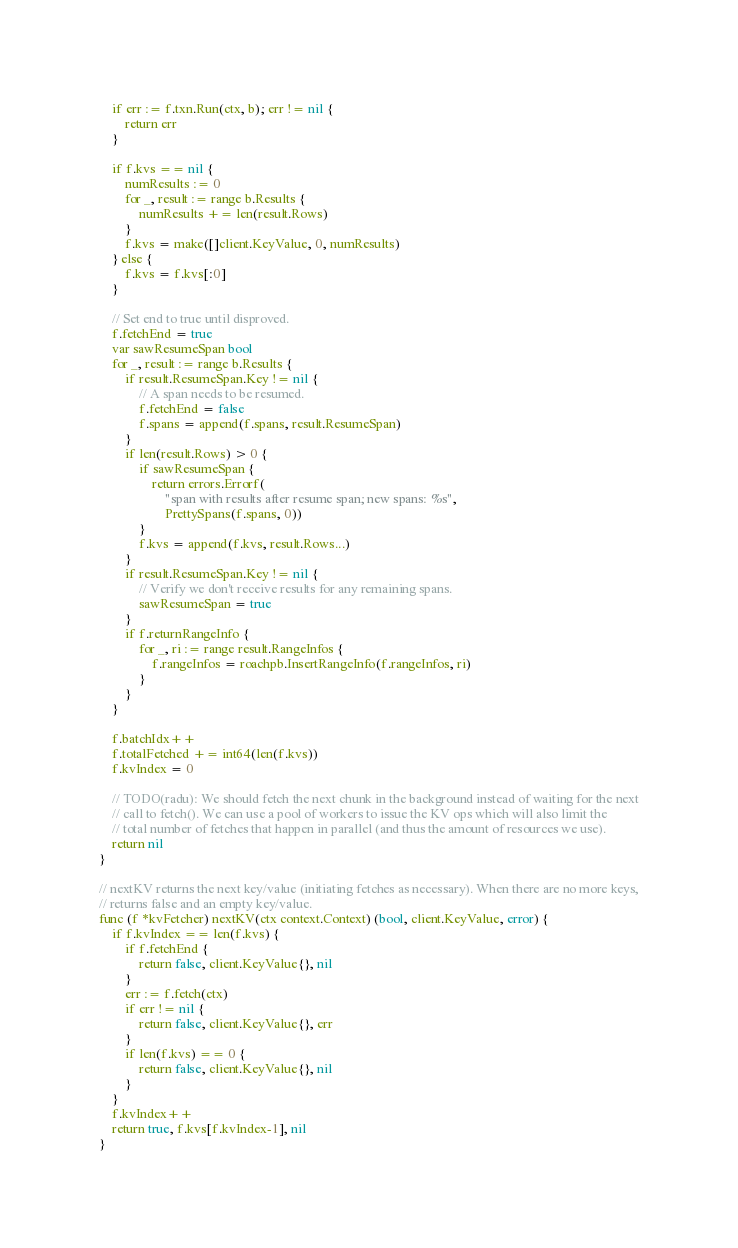<code> <loc_0><loc_0><loc_500><loc_500><_Go_>	if err := f.txn.Run(ctx, b); err != nil {
		return err
	}

	if f.kvs == nil {
		numResults := 0
		for _, result := range b.Results {
			numResults += len(result.Rows)
		}
		f.kvs = make([]client.KeyValue, 0, numResults)
	} else {
		f.kvs = f.kvs[:0]
	}

	// Set end to true until disproved.
	f.fetchEnd = true
	var sawResumeSpan bool
	for _, result := range b.Results {
		if result.ResumeSpan.Key != nil {
			// A span needs to be resumed.
			f.fetchEnd = false
			f.spans = append(f.spans, result.ResumeSpan)
		}
		if len(result.Rows) > 0 {
			if sawResumeSpan {
				return errors.Errorf(
					"span with results after resume span; new spans: %s",
					PrettySpans(f.spans, 0))
			}
			f.kvs = append(f.kvs, result.Rows...)
		}
		if result.ResumeSpan.Key != nil {
			// Verify we don't receive results for any remaining spans.
			sawResumeSpan = true
		}
		if f.returnRangeInfo {
			for _, ri := range result.RangeInfos {
				f.rangeInfos = roachpb.InsertRangeInfo(f.rangeInfos, ri)
			}
		}
	}

	f.batchIdx++
	f.totalFetched += int64(len(f.kvs))
	f.kvIndex = 0

	// TODO(radu): We should fetch the next chunk in the background instead of waiting for the next
	// call to fetch(). We can use a pool of workers to issue the KV ops which will also limit the
	// total number of fetches that happen in parallel (and thus the amount of resources we use).
	return nil
}

// nextKV returns the next key/value (initiating fetches as necessary). When there are no more keys,
// returns false and an empty key/value.
func (f *kvFetcher) nextKV(ctx context.Context) (bool, client.KeyValue, error) {
	if f.kvIndex == len(f.kvs) {
		if f.fetchEnd {
			return false, client.KeyValue{}, nil
		}
		err := f.fetch(ctx)
		if err != nil {
			return false, client.KeyValue{}, err
		}
		if len(f.kvs) == 0 {
			return false, client.KeyValue{}, nil
		}
	}
	f.kvIndex++
	return true, f.kvs[f.kvIndex-1], nil
}
</code> 